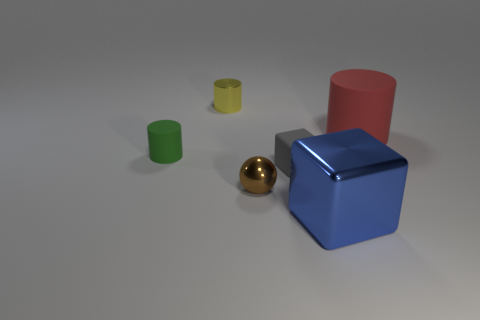Is the number of yellow cylinders on the right side of the small yellow cylinder the same as the number of big things? No, there is only one yellow cylinder to the right of the small yellow cylinder in the image, whereas there are three large objects in total—a blue cube, a red cylinder, and a green cylinder. 